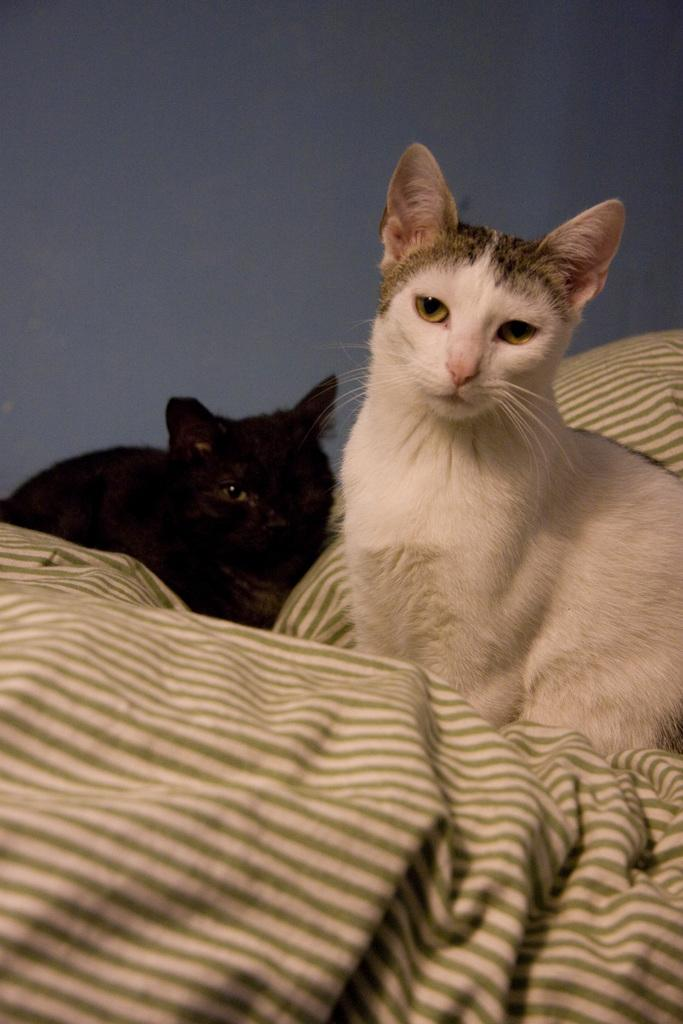How many cats are present in the image? There are two cats in the image. Where are the cats located in the image? The cats are sitting on a bed. What type of egg can be seen in the image? There is no egg present in the image; it features two cats sitting on a bed. What type of wood is used to construct the bed in the image? The image does not provide enough detail to determine the type of wood used to construct the bed. 